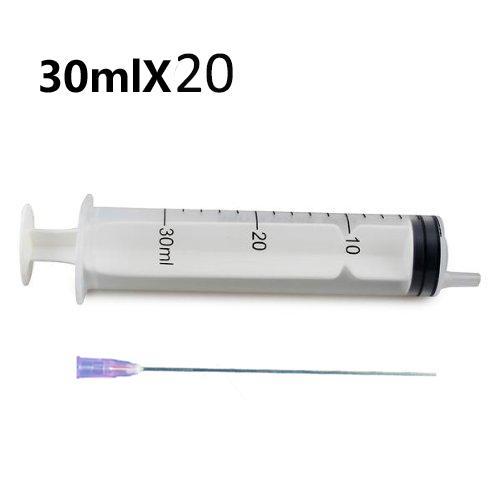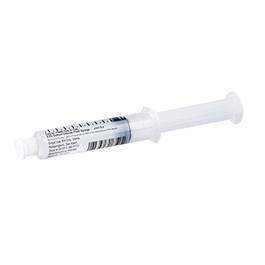The first image is the image on the left, the second image is the image on the right. Assess this claim about the two images: "Both syringes are exactly horizontal.". Correct or not? Answer yes or no. No. 